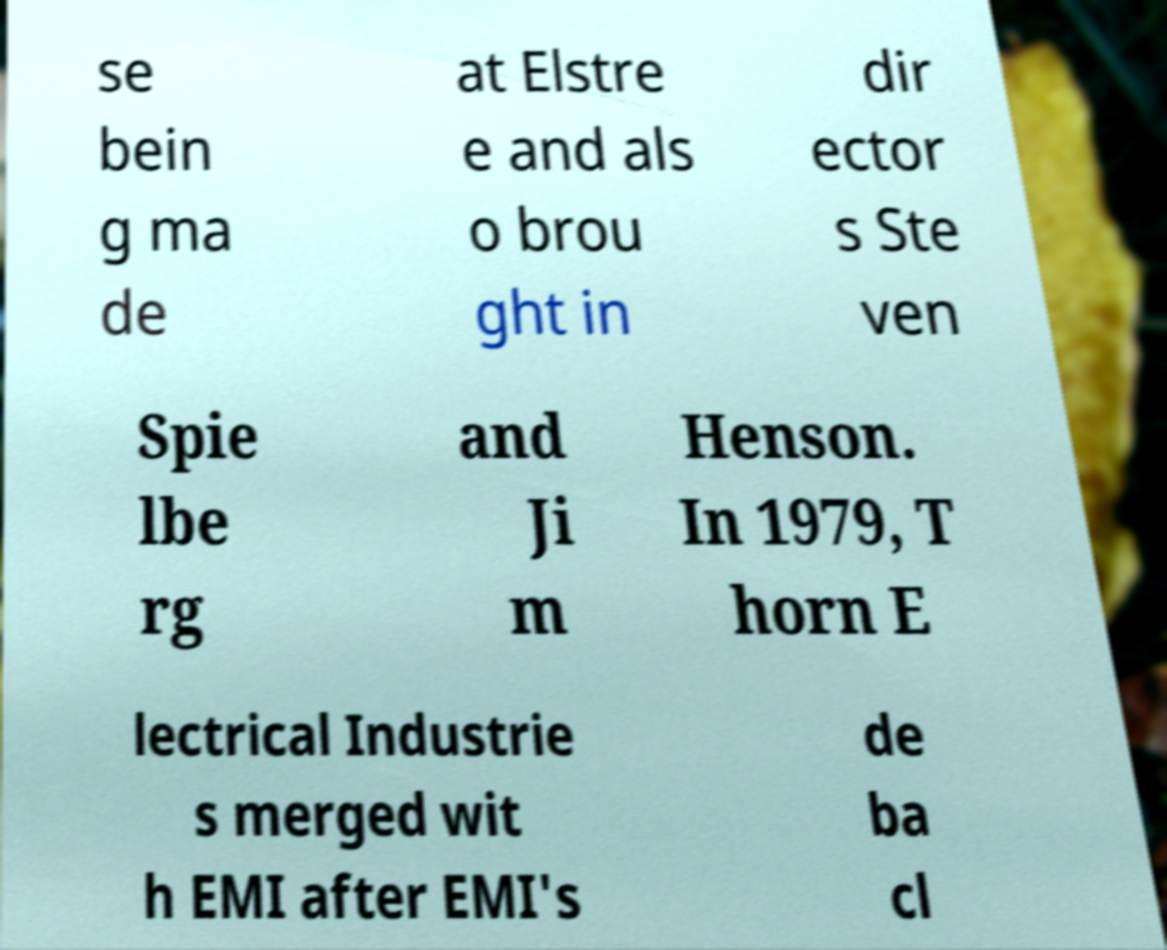Please read and relay the text visible in this image. What does it say? se bein g ma de at Elstre e and als o brou ght in dir ector s Ste ven Spie lbe rg and Ji m Henson. In 1979, T horn E lectrical Industrie s merged wit h EMI after EMI's de ba cl 